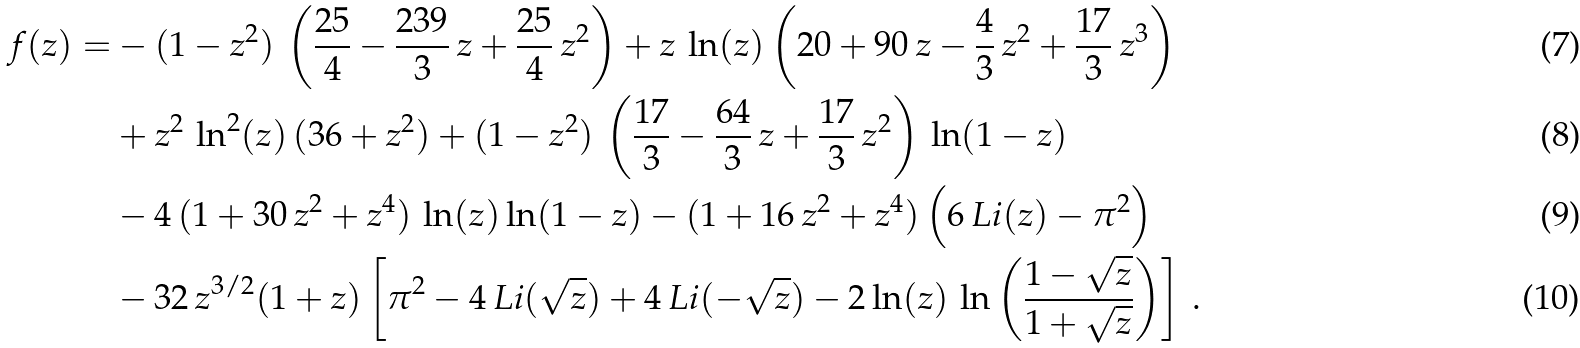<formula> <loc_0><loc_0><loc_500><loc_500>f ( z ) = & - ( 1 - z ^ { 2 } ) \, \left ( \frac { 2 5 } { 4 } - \frac { 2 3 9 } { 3 } \, z + \frac { 2 5 } { 4 } \, z ^ { 2 } \right ) + z \, \ln ( z ) \left ( 2 0 + 9 0 \, z - \frac { 4 } { 3 } \, z ^ { 2 } + \frac { 1 7 } { 3 } \, z ^ { 3 } \right ) \\ & + z ^ { 2 } \, \ln ^ { 2 } ( z ) \, ( 3 6 + z ^ { 2 } ) + ( 1 - z ^ { 2 } ) \, \left ( \frac { 1 7 } { 3 } - \frac { 6 4 } { 3 } \, z + \frac { 1 7 } { 3 } \, z ^ { 2 } \right ) \, \ln ( 1 - z ) \\ & - 4 \, ( 1 + 3 0 \, z ^ { 2 } + z ^ { 4 } ) \, \ln ( z ) \ln ( 1 - z ) - ( 1 + 1 6 \, z ^ { 2 } + z ^ { 4 } ) \left ( 6 \, L i ( z ) - \pi ^ { 2 } \right ) \\ & - 3 2 \, z ^ { 3 / 2 } ( 1 + z ) \left [ \pi ^ { 2 } - 4 \, L i ( \sqrt { z } ) + 4 \, L i ( - \sqrt { z } ) - 2 \ln ( z ) \, \ln \left ( \frac { 1 - \sqrt { z } } { 1 + \sqrt { z } } \right ) \right ] \, .</formula> 